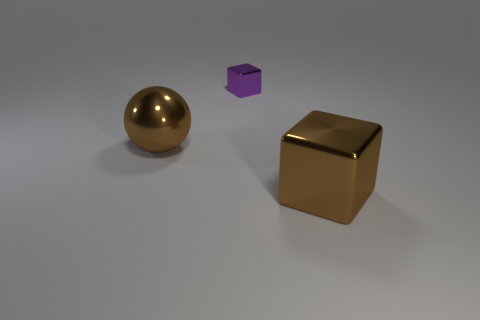Do the large sphere and the large metal cube have the same color?
Your response must be concise. Yes. What number of shiny objects have the same color as the large metallic block?
Give a very brief answer. 1. Are there any large brown objects that have the same shape as the purple object?
Keep it short and to the point. Yes. Is there a brown shiny thing that is behind the brown metallic object that is in front of the thing that is to the left of the tiny cube?
Ensure brevity in your answer.  Yes. Are there more brown metal spheres behind the large metallic block than brown spheres that are right of the large brown shiny ball?
Your answer should be very brief. Yes. What is the material of the cube that is the same size as the sphere?
Offer a very short reply. Metal. What number of small things are either balls or blue metallic blocks?
Provide a short and direct response. 0. What number of metallic objects are both on the right side of the ball and in front of the purple metal cube?
Offer a very short reply. 1. Is there anything else that is the same color as the big shiny cube?
Provide a short and direct response. Yes. What is the shape of the brown thing that is made of the same material as the large block?
Ensure brevity in your answer.  Sphere. 